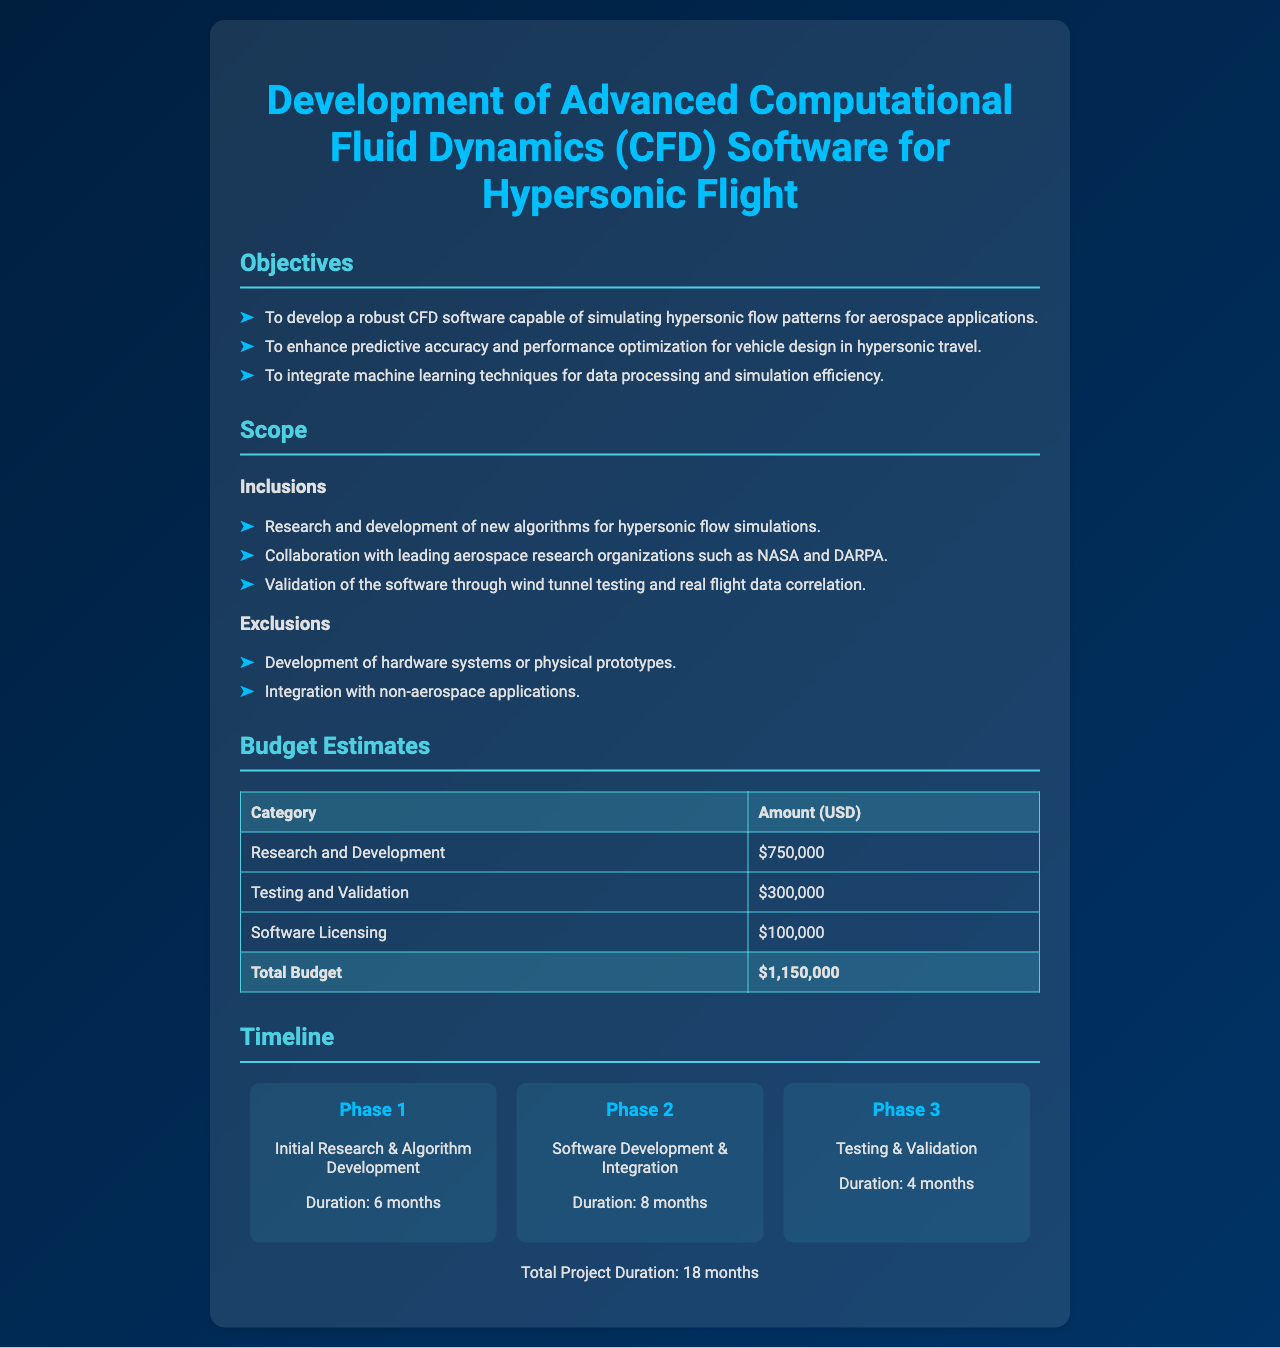what is the title of the project proposal? The title of the project proposal is mentioned at the top of the document.
Answer: Development of Advanced Computational Fluid Dynamics (CFD) Software for Hypersonic Flight how many objectives are listed in the document? The number of objectives is provided in the objectives section of the document.
Answer: 3 what is the total budget estimate? The total budget estimate is specified in the budget estimates section of the document.
Answer: $1,150,000 who are the collaborating organizations mentioned? The collaborating organizations are mentioned in the scope section of the document.
Answer: NASA and DARPA what is the duration of Phase 2? The duration of Phase 2 is explicitly stated in the timeline section of the document.
Answer: 8 months which phase focuses on testing? The phase that focuses on testing is indicated in the timeline section of the document.
Answer: Phase 3 how much is allocated to software licensing? The amount allocated to software licensing is listed in the budget estimates table.
Answer: $100,000 what type of applications are excluded from the project's scope? The excluded applications are mentioned in the scope exclusions section of the document.
Answer: Non-aerospace applications what is the total project duration? The total project duration is summarized at the end of the timeline section of the document.
Answer: 18 months 